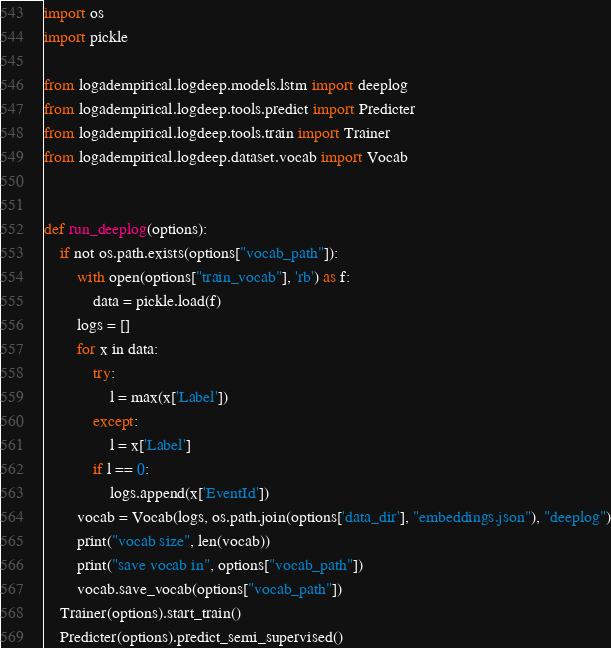<code> <loc_0><loc_0><loc_500><loc_500><_Python_>import os
import pickle

from logadempirical.logdeep.models.lstm import deeplog
from logadempirical.logdeep.tools.predict import Predicter
from logadempirical.logdeep.tools.train import Trainer
from logadempirical.logdeep.dataset.vocab import Vocab


def run_deeplog(options):
    if not os.path.exists(options["vocab_path"]):
        with open(options["train_vocab"], 'rb') as f:
            data = pickle.load(f)
        logs = []
        for x in data:
            try:
                l = max(x['Label'])
            except:
                l = x['Label']
            if l == 0:
                logs.append(x['EventId'])
        vocab = Vocab(logs, os.path.join(options['data_dir'], "embeddings.json"), "deeplog")
        print("vocab size", len(vocab))
        print("save vocab in", options["vocab_path"])
        vocab.save_vocab(options["vocab_path"])
    Trainer(options).start_train()
    Predicter(options).predict_semi_supervised()
</code> 